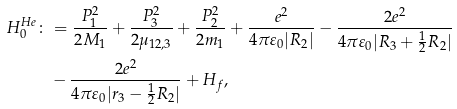<formula> <loc_0><loc_0><loc_500><loc_500>H _ { 0 } ^ { H e } \colon & = \frac { P _ { 1 } ^ { 2 } } { 2 M _ { 1 } } + \frac { P _ { 3 } ^ { 2 } } { 2 \mu _ { 1 2 , 3 } } + \frac { P _ { 2 } ^ { 2 } } { 2 m _ { 1 } } + \frac { e ^ { 2 } } { 4 \pi \varepsilon _ { 0 } | R _ { 2 } | } - \frac { 2 e ^ { 2 } } { 4 \pi \varepsilon _ { 0 } | R _ { 3 } + \frac { 1 } { 2 } R _ { 2 } | } \\ & - \frac { 2 e ^ { 2 } } { 4 \pi \varepsilon _ { 0 } | r _ { 3 } - \frac { 1 } { 2 } R _ { 2 } | } + H _ { f } ,</formula> 